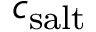Convert formula to latex. <formula><loc_0><loc_0><loc_500><loc_500>c _ { s a l t }</formula> 